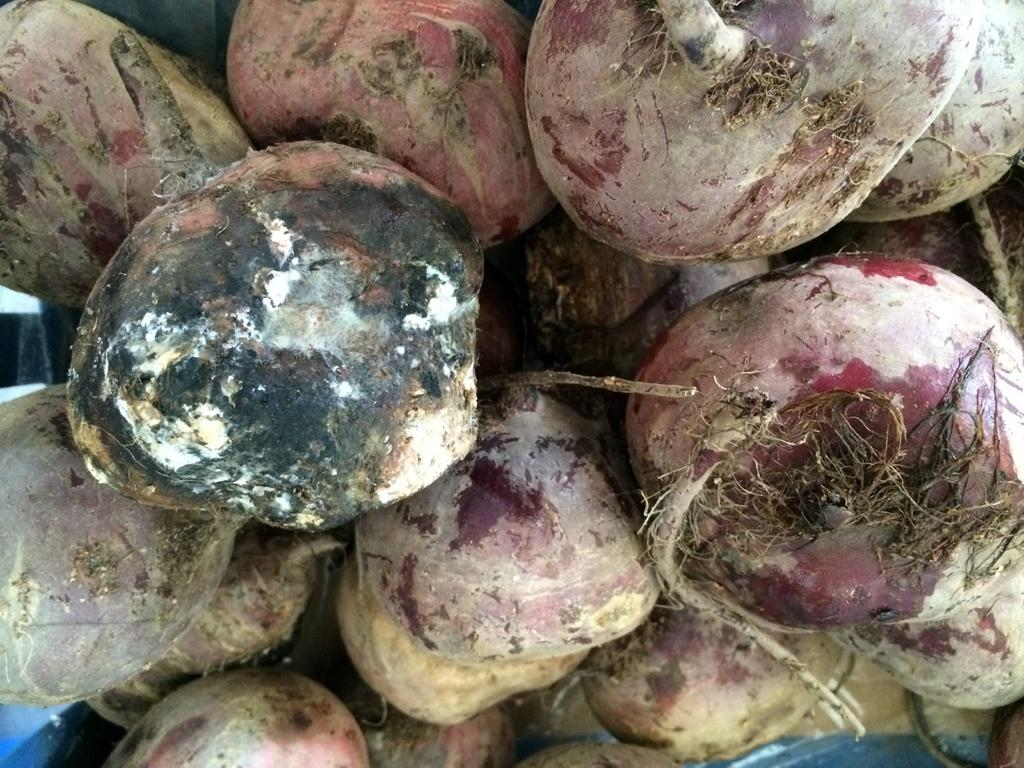What type of vegetables are present in the image? There are many beetroots in the image. Can you describe the quantity of beetroots in the image? The image contains a large number of beetroots. What color are the beetroots in the image? The beetroots in the image are typically red or purple. How many women are adjusting the chalk in the image? There are no women or chalk present in the image; it only contains beetroots. 